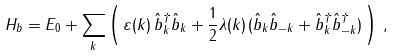Convert formula to latex. <formula><loc_0><loc_0><loc_500><loc_500>H _ { b } = E _ { 0 } + \sum _ { k } \left ( \, \varepsilon ( { k } ) \, \hat { b } ^ { \dagger } _ { k } \hat { b } _ { k } + \frac { 1 } { 2 } \lambda ( { k } ) \, ( \hat { b } _ { k } \hat { b } _ { - { k } } + \hat { b } ^ { \dagger } _ { k } \hat { b } ^ { \dagger } _ { - { k } } ) \, \right ) \, ,</formula> 